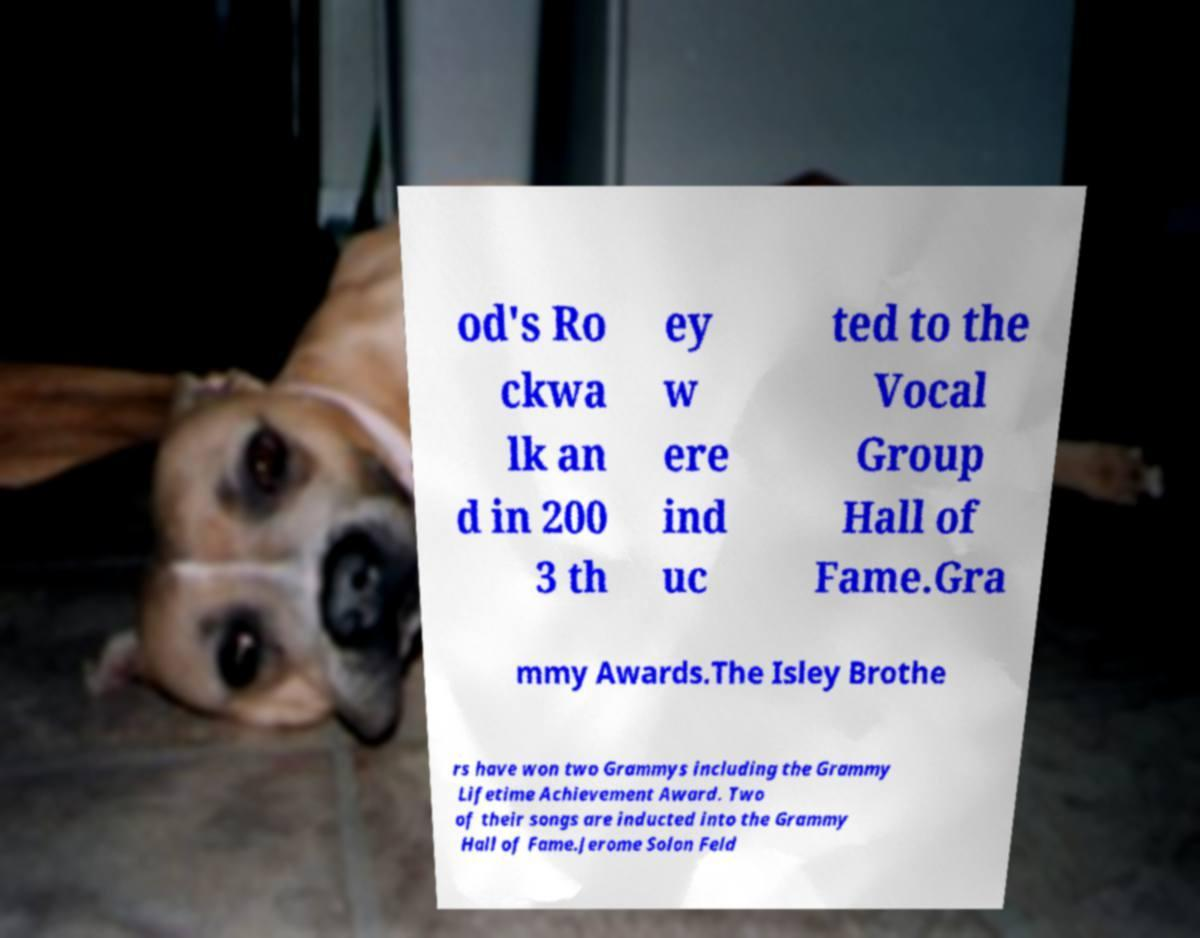Could you extract and type out the text from this image? od's Ro ckwa lk an d in 200 3 th ey w ere ind uc ted to the Vocal Group Hall of Fame.Gra mmy Awards.The Isley Brothe rs have won two Grammys including the Grammy Lifetime Achievement Award. Two of their songs are inducted into the Grammy Hall of Fame.Jerome Solon Feld 